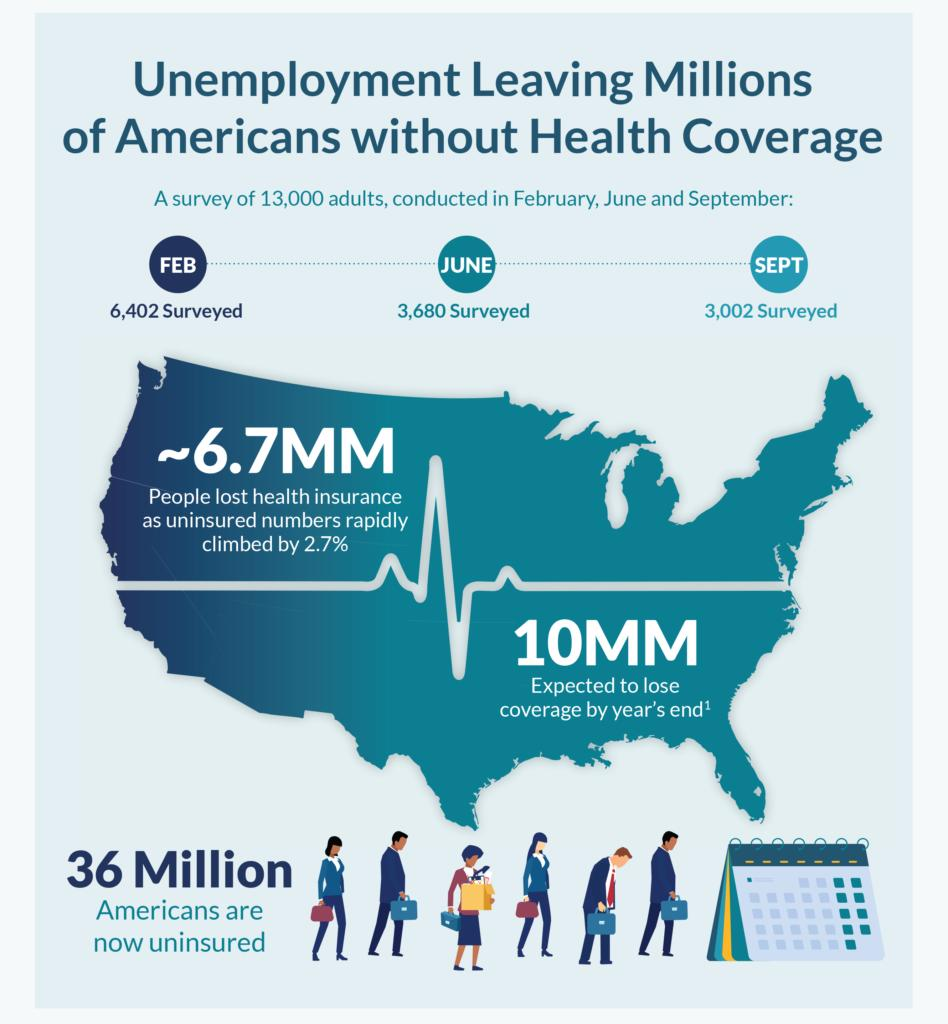Specify some key components in this picture. What is the total count of Saturdays and Sundays in the calendar? It is 9 in total. The color of the tie of the person who is stooping is red. In June, more people were surveyed than in September. Specifically, 678 more people were surveyed in June when compared to September. In February, a total of 6,402 people were surveyed. 